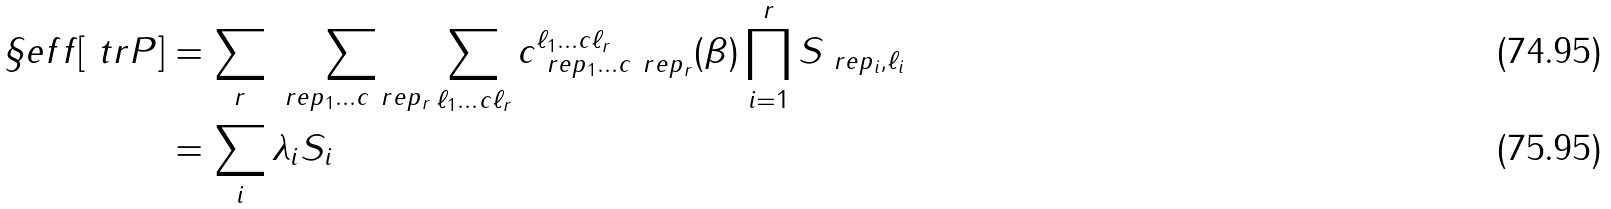<formula> <loc_0><loc_0><loc_500><loc_500>\S e f f [ \ t r P ] & = \sum _ { r } \sum _ { \ r e p _ { 1 } \dots c \ r e p _ { r } } \sum _ { \ell _ { 1 } \dots c \ell _ { r } } c _ { \ r e p _ { 1 } \dots c \ r e p _ { r } } ^ { \ell _ { 1 } \dots c \ell _ { r } } ( \beta ) \prod _ { i = 1 } ^ { r } S _ { \ r e p _ { i } , \ell _ { i } } \\ & = \sum _ { i } \lambda _ { i } S _ { i }</formula> 